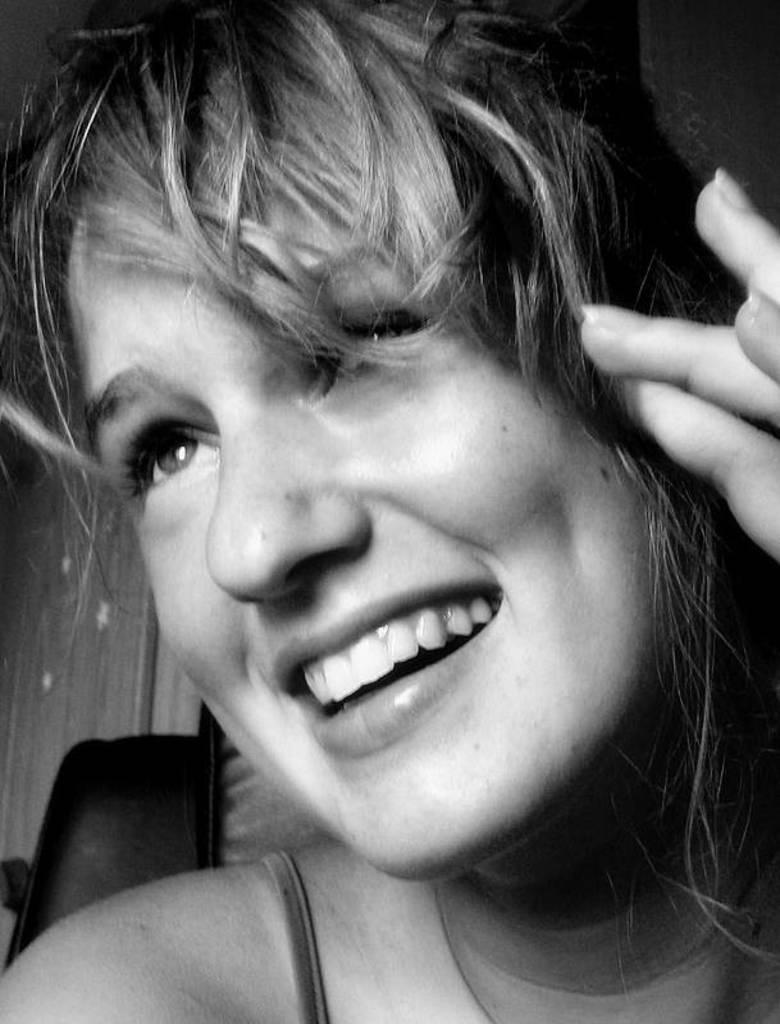Can you describe this image briefly? In the picture there is a woman present. 